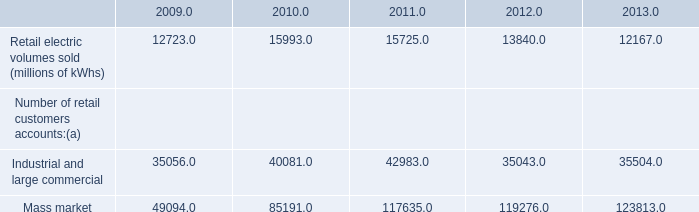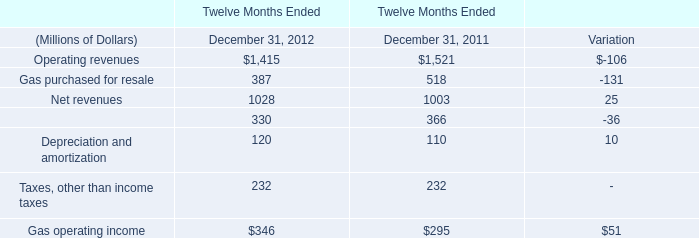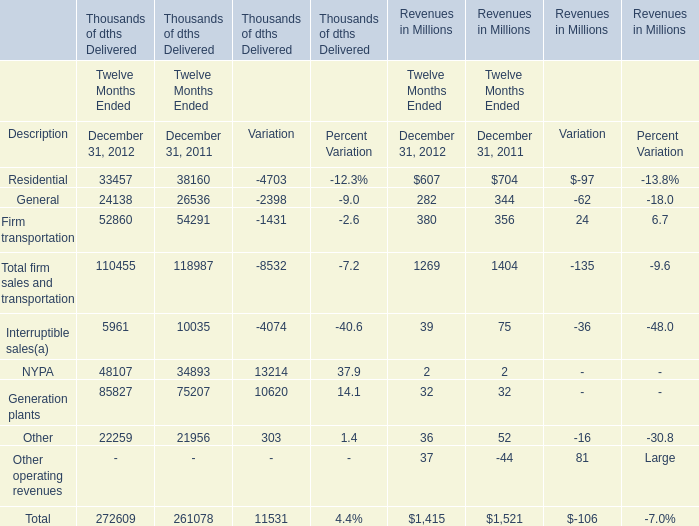What will Firm transportation Revenues reach in 2013 if it continues to grow at its current rate? (in million) 
Computations: (380 * (1 + 0.067))
Answer: 405.46. 